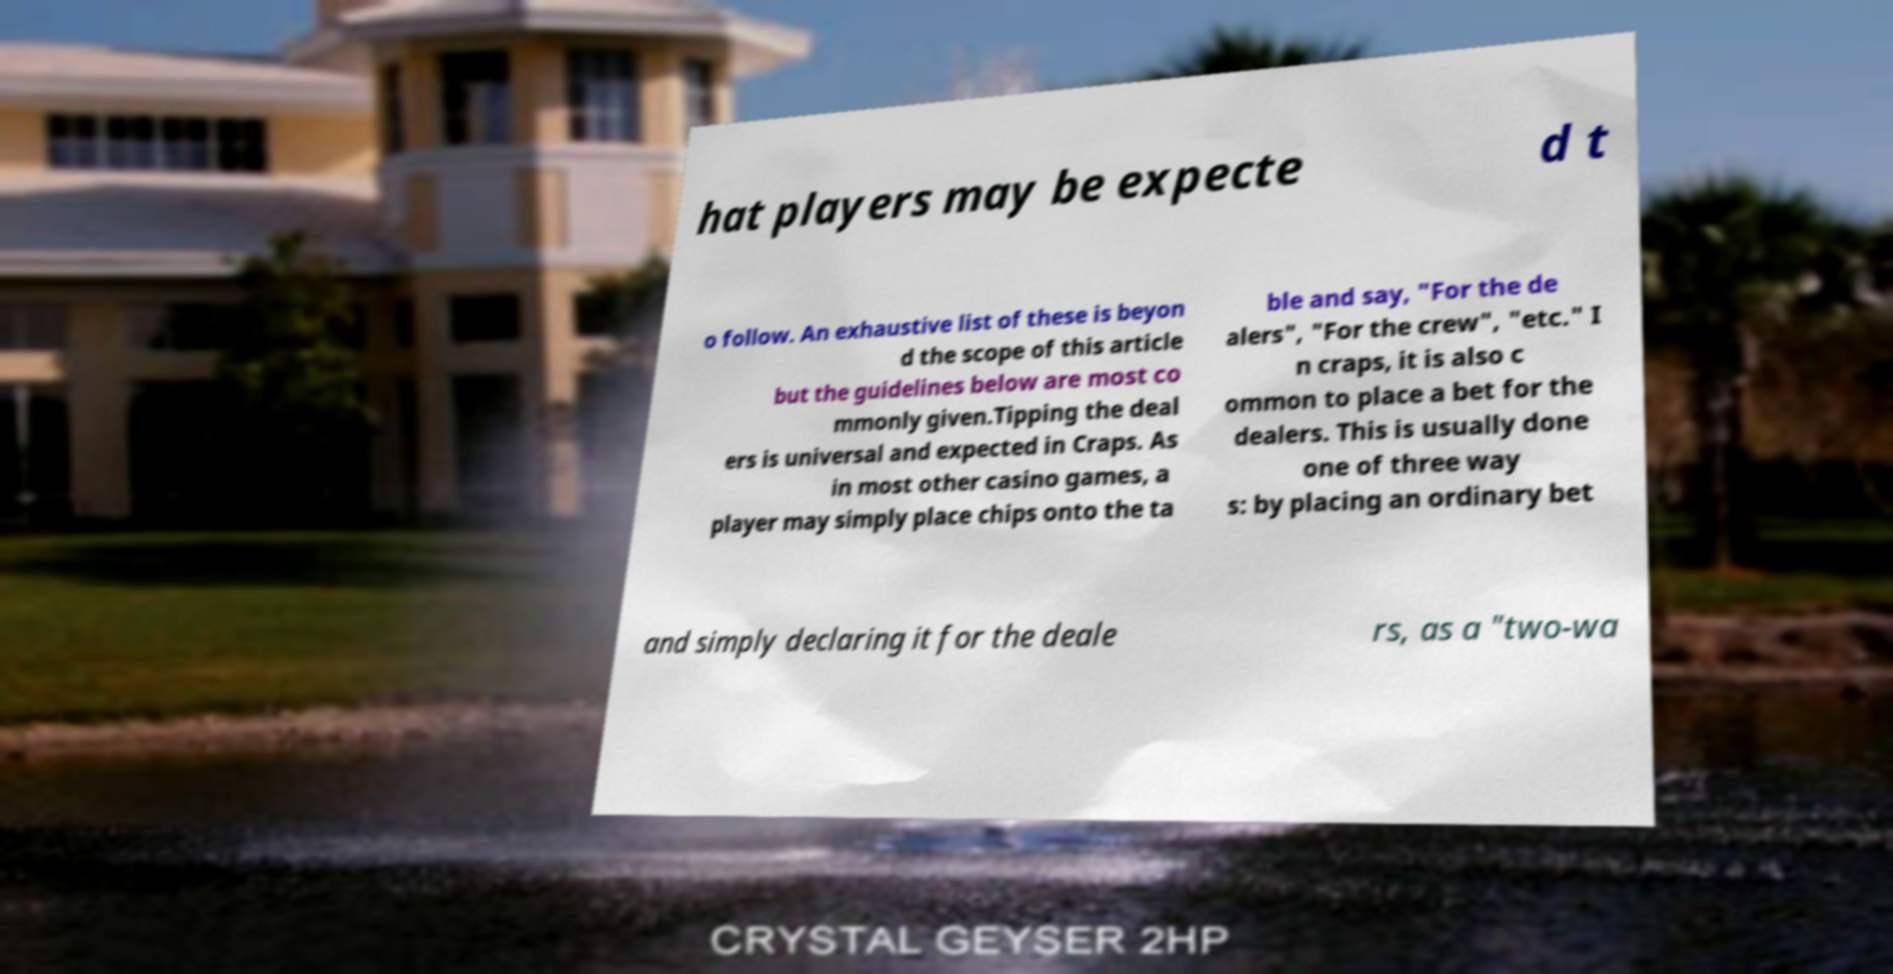I need the written content from this picture converted into text. Can you do that? hat players may be expecte d t o follow. An exhaustive list of these is beyon d the scope of this article but the guidelines below are most co mmonly given.Tipping the deal ers is universal and expected in Craps. As in most other casino games, a player may simply place chips onto the ta ble and say, "For the de alers", "For the crew", "etc." I n craps, it is also c ommon to place a bet for the dealers. This is usually done one of three way s: by placing an ordinary bet and simply declaring it for the deale rs, as a "two-wa 